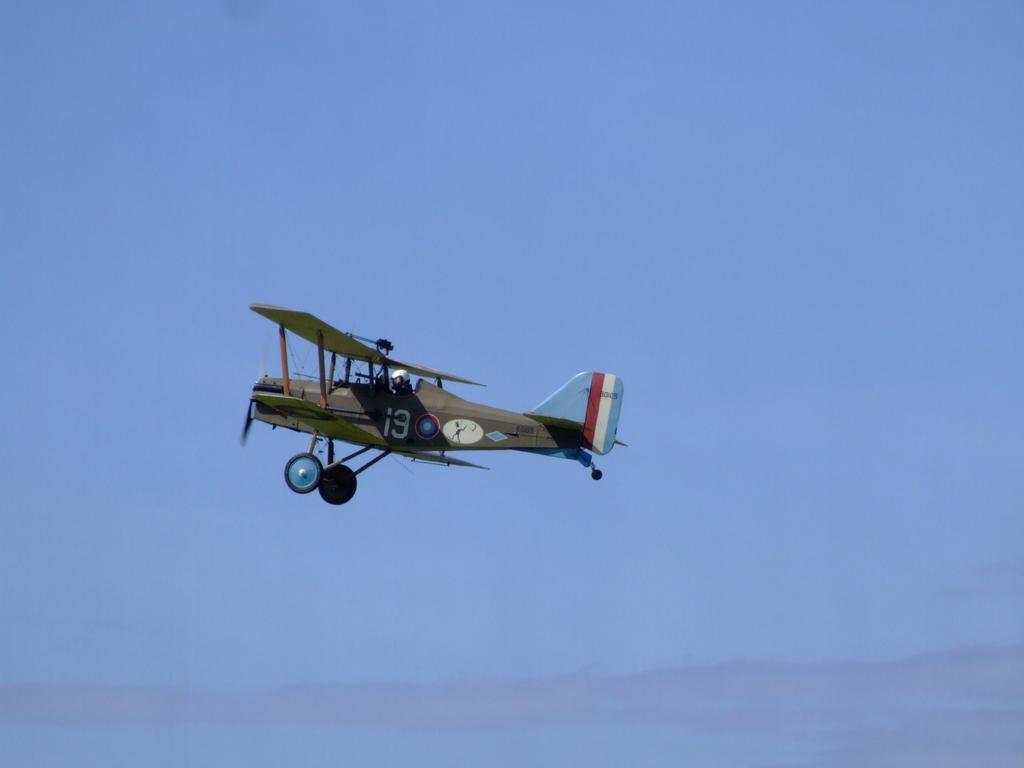Could you give a brief overview of what you see in this image? This picture is clicked outside. In the center we can see a person wearing helmet and flying an aircraft in the air. In the background we can see the sky. 